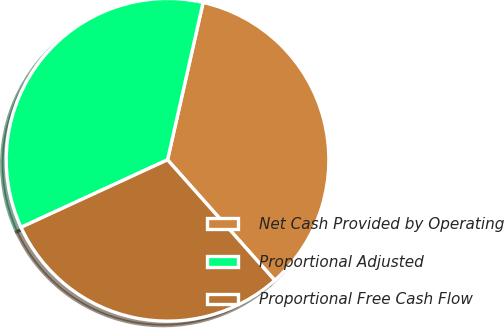Convert chart. <chart><loc_0><loc_0><loc_500><loc_500><pie_chart><fcel>Net Cash Provided by Operating<fcel>Proportional Adjusted<fcel>Proportional Free Cash Flow<nl><fcel>34.89%<fcel>35.41%<fcel>29.69%<nl></chart> 